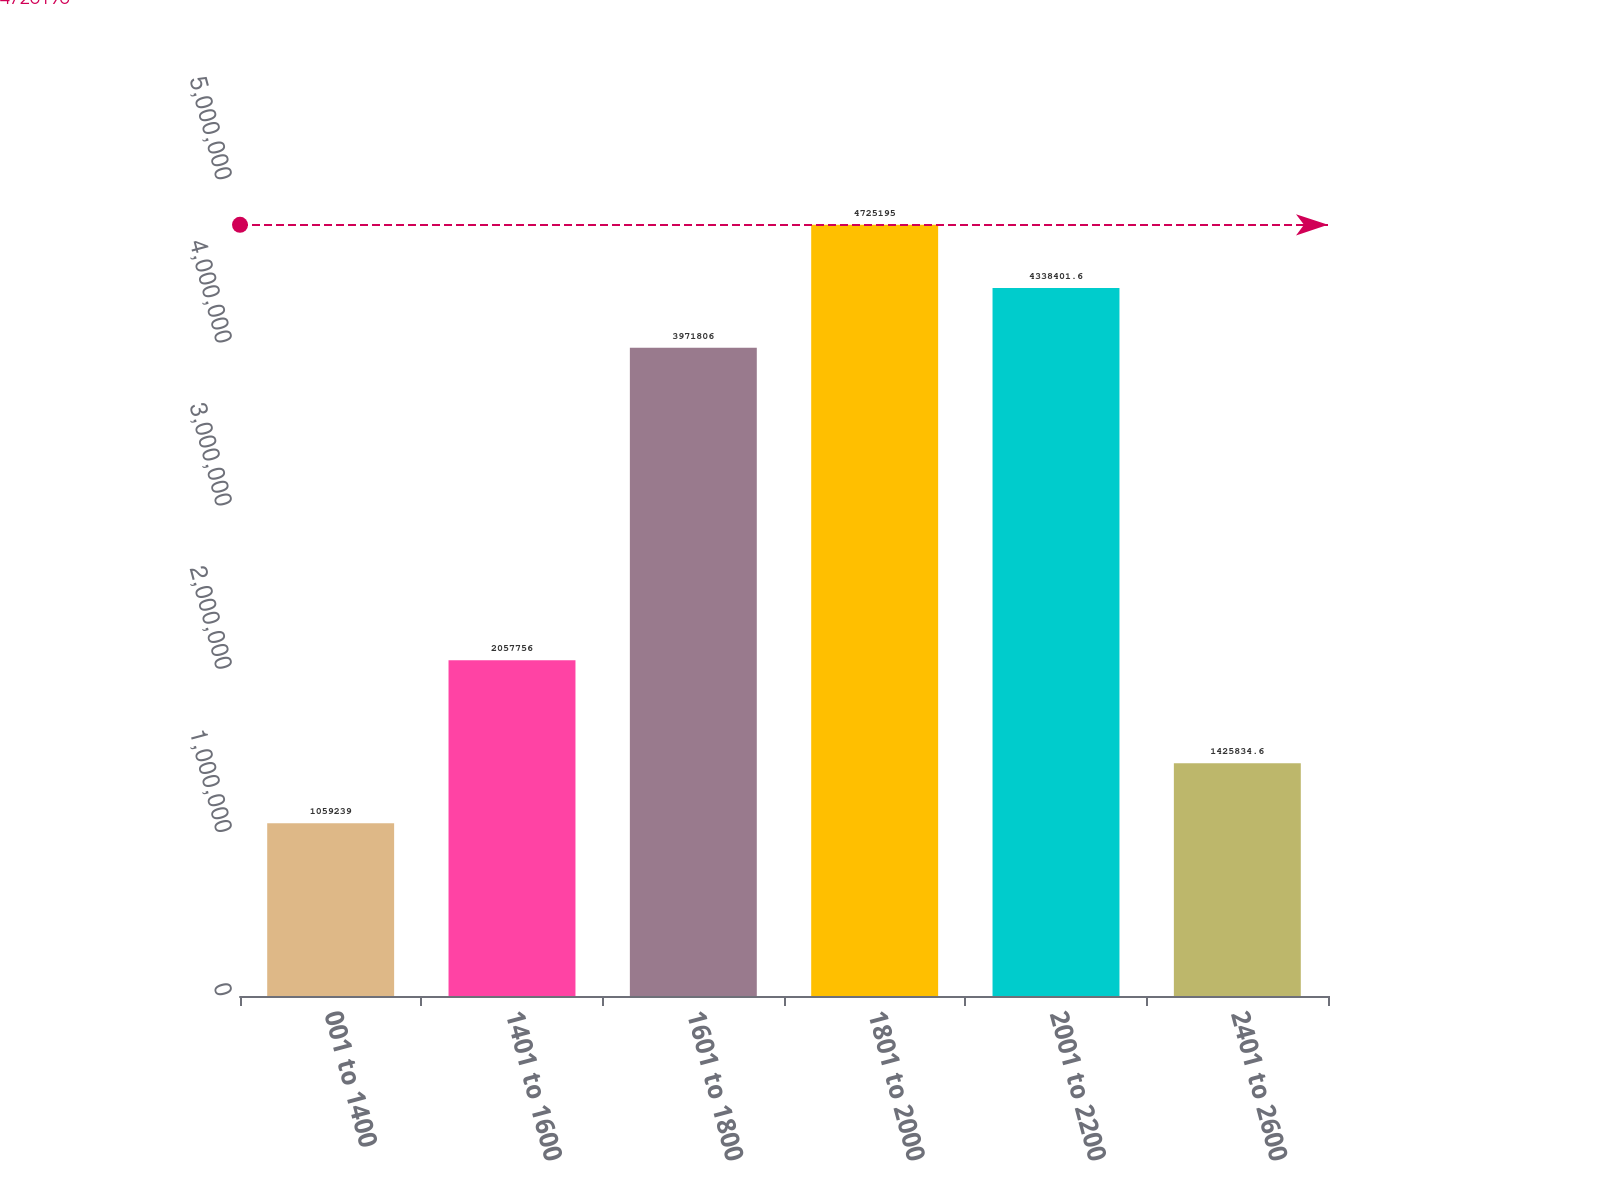Convert chart. <chart><loc_0><loc_0><loc_500><loc_500><bar_chart><fcel>001 to 1400<fcel>1401 to 1600<fcel>1601 to 1800<fcel>1801 to 2000<fcel>2001 to 2200<fcel>2401 to 2600<nl><fcel>1.05924e+06<fcel>2.05776e+06<fcel>3.97181e+06<fcel>4.7252e+06<fcel>4.3384e+06<fcel>1.42583e+06<nl></chart> 